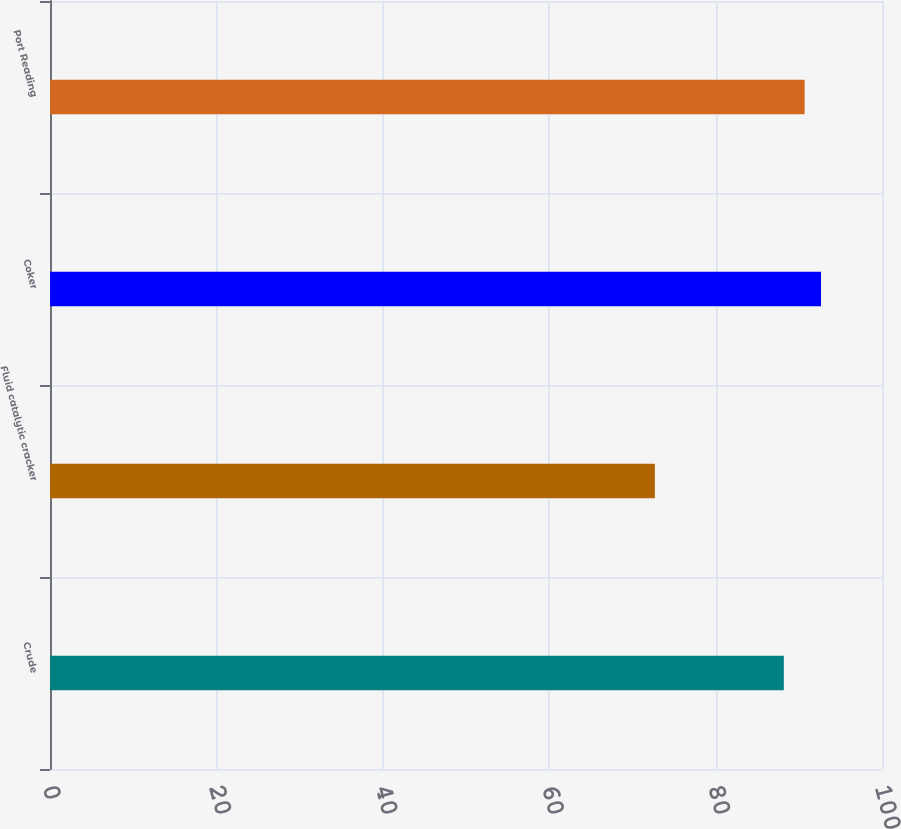<chart> <loc_0><loc_0><loc_500><loc_500><bar_chart><fcel>Crude<fcel>Fluid catalytic cracker<fcel>Coker<fcel>Port Reading<nl><fcel>88.2<fcel>72.7<fcel>92.67<fcel>90.7<nl></chart> 